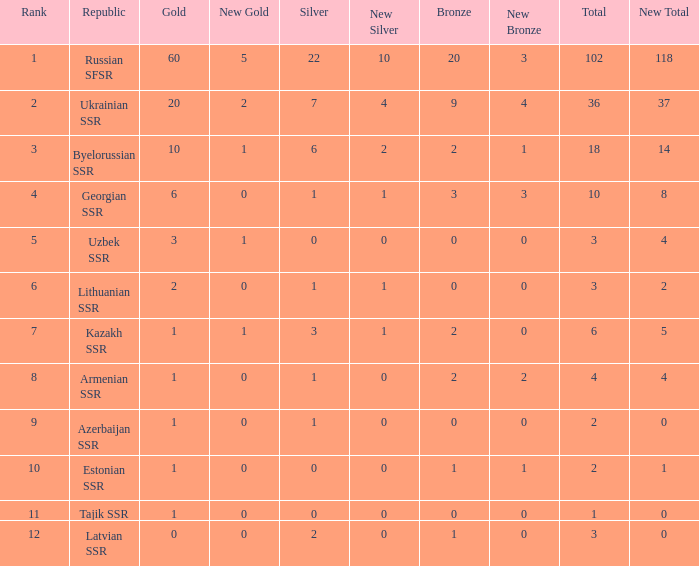What is the sum of bronzes for teams with more than 2 gold, ranked under 3, and less than 22 silver? 9.0. 